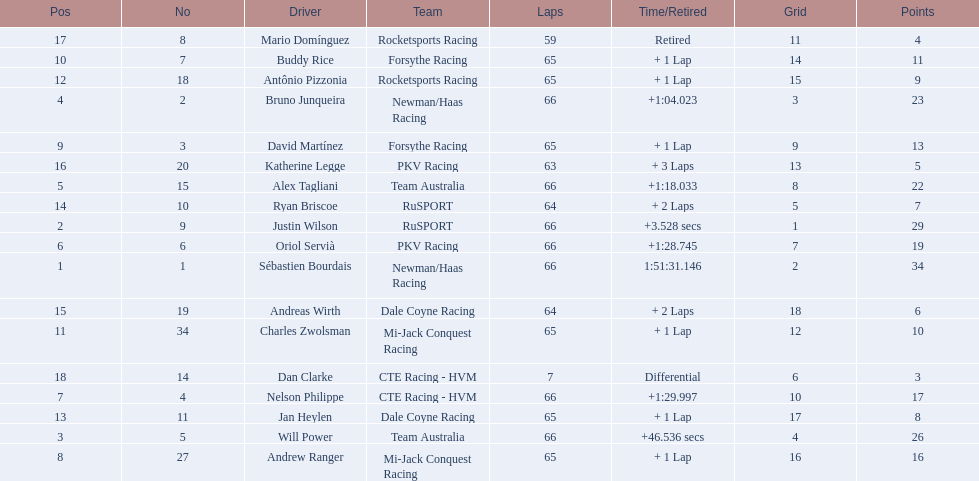Who are all the drivers? Sébastien Bourdais, Justin Wilson, Will Power, Bruno Junqueira, Alex Tagliani, Oriol Servià, Nelson Philippe, Andrew Ranger, David Martínez, Buddy Rice, Charles Zwolsman, Antônio Pizzonia, Jan Heylen, Ryan Briscoe, Andreas Wirth, Katherine Legge, Mario Domínguez, Dan Clarke. What position did they reach? 1, 2, 3, 4, 5, 6, 7, 8, 9, 10, 11, 12, 13, 14, 15, 16, 17, 18. What is the number for each driver? 1, 9, 5, 2, 15, 6, 4, 27, 3, 7, 34, 18, 11, 10, 19, 20, 8, 14. And which player's number and position match? Sébastien Bourdais. 